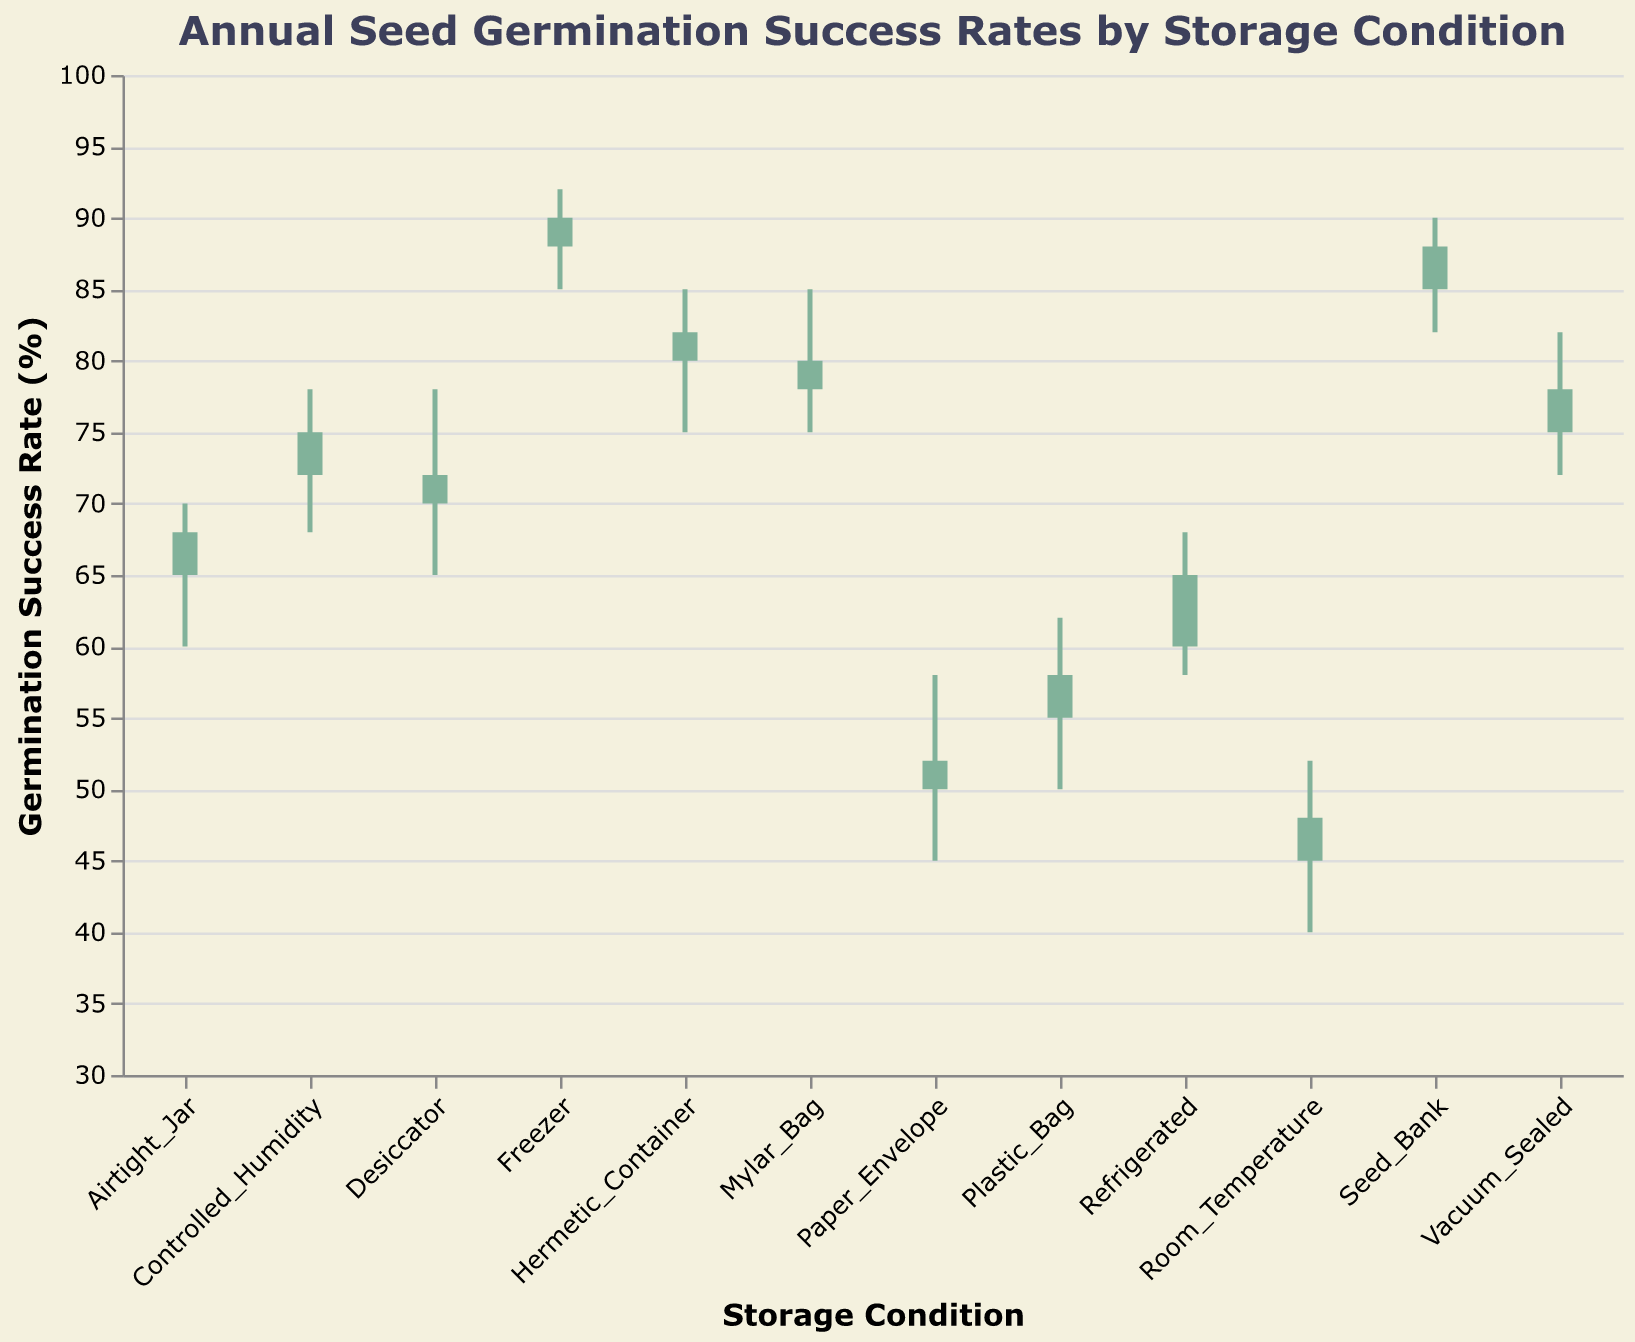What is the title of the figure? The title of the figure is displayed at the top of the chart and reads "Annual Seed Germination Success Rates by Storage Condition."
Answer: Annual Seed Germination Success Rates by Storage Condition Which storage condition has the highest Close value? By examining the Close values of each storage condition, the highest Close value is seen in the Freezer condition with a Close value of 90.
Answer: Freezer Which storage condition has the lowest Low value? By identifying the lowest Low values among all storage conditions, Room Temperature has the lowest Low value of 40.
Answer: Room Temperature For which storage condition does Open equal Close? In the figure, Open and Close values are equal when there is no color fill in the OHLC bars. This occurs for the "Airtight Jar" condition where both Open and Close are 65.
Answer: Airtight Jar What is the color of the bars when Open is less than Close? The bars turn green when the Open value is less than the Close value, which indicates germination rates have increased.
Answer: Green Which storage condition shows the largest difference between High and Low values? To find the largest difference between High and Low values, calculate the spread (High - Low) for each condition. The condition with the largest spread is the Seed Bank with a difference of (90 - 82) = 8.
Answer: Seed Bank What is the average Close value for all storage conditions? First, sum all Close values: 48 + 65 + 78 + 72 + 88 + 82 + 75 + 90 + 68 + 52 + 58 + 80 = 856. Then divide by the number of conditions, which is 12. The average Close value is 856 / 12 ≈ 71.33.
Answer: 71.33 Which storage conditions show a positive change from Open to Close? Positive changes are indicated by green bars. These conditions are Room Temperature, Refrigerated, Vacuum Sealed, Seed Bank, Controlled Humidity, Freezer, Plastic Bag, and Mylar Bag.
Answer: Room Temperature, Refrigerated, Vacuum Sealed, Seed Bank, Controlled Humidity, Freezer, Plastic Bag, Mylar Bag What is the median Low value of the storage conditions? To find the median Low value, first sort the Low values: 40, 45, 50, 58, 60, 65, 68, 72, 75, 75, 75, 82. The median of these 12 values (average of the 6th and 7th) is (65 + 68) / 2 = 66.5.
Answer: 66.5 